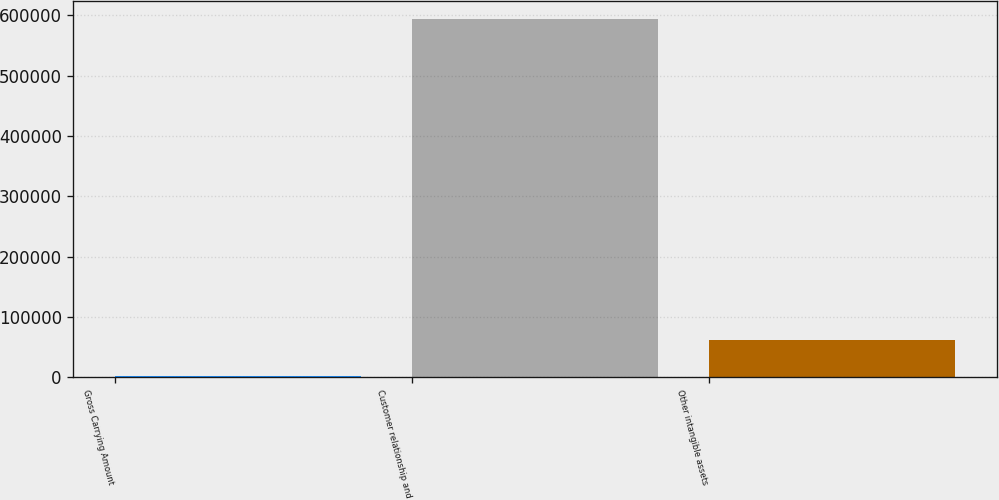Convert chart. <chart><loc_0><loc_0><loc_500><loc_500><bar_chart><fcel>Gross Carrying Amount<fcel>Customer relationship and<fcel>Other intangible assets<nl><fcel>2011<fcel>593901<fcel>61200<nl></chart> 